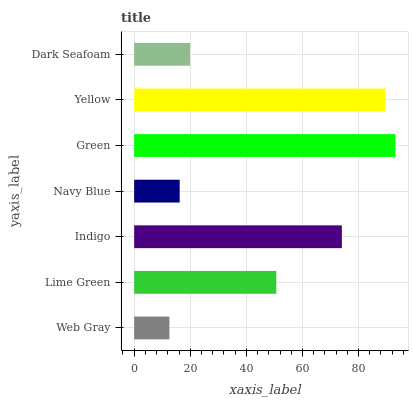Is Web Gray the minimum?
Answer yes or no. Yes. Is Green the maximum?
Answer yes or no. Yes. Is Lime Green the minimum?
Answer yes or no. No. Is Lime Green the maximum?
Answer yes or no. No. Is Lime Green greater than Web Gray?
Answer yes or no. Yes. Is Web Gray less than Lime Green?
Answer yes or no. Yes. Is Web Gray greater than Lime Green?
Answer yes or no. No. Is Lime Green less than Web Gray?
Answer yes or no. No. Is Lime Green the high median?
Answer yes or no. Yes. Is Lime Green the low median?
Answer yes or no. Yes. Is Web Gray the high median?
Answer yes or no. No. Is Green the low median?
Answer yes or no. No. 